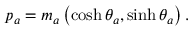Convert formula to latex. <formula><loc_0><loc_0><loc_500><loc_500>p _ { a } = m _ { a } \left ( \cosh \theta _ { a } , \sinh \theta _ { a } \right ) .</formula> 